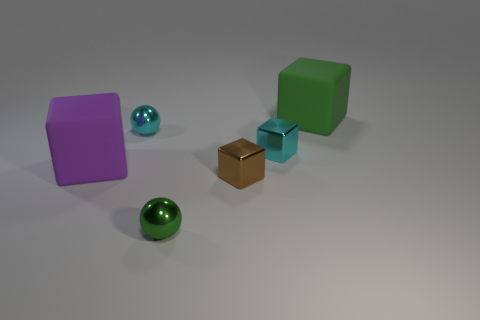The shiny thing behind the metallic object that is to the right of the tiny brown shiny thing is what shape?
Your answer should be compact. Sphere. Are there fewer large green matte objects than cubes?
Offer a terse response. Yes. Is the cyan sphere made of the same material as the large green block?
Offer a very short reply. No. There is a thing that is left of the brown metallic cube and in front of the purple object; what is its color?
Provide a succinct answer. Green. Are there any other purple things of the same size as the purple object?
Offer a very short reply. No. There is a rubber block in front of the rubber cube that is on the right side of the small green sphere; what size is it?
Your answer should be very brief. Large. Is the number of metallic balls on the left side of the big green rubber cube less than the number of purple rubber things?
Keep it short and to the point. No. What size is the green block?
Provide a short and direct response. Large. Is there a cyan thing that is right of the ball that is in front of the tiny brown block left of the green cube?
Your answer should be very brief. Yes. There is a green shiny thing that is the same size as the brown thing; what shape is it?
Provide a succinct answer. Sphere. 